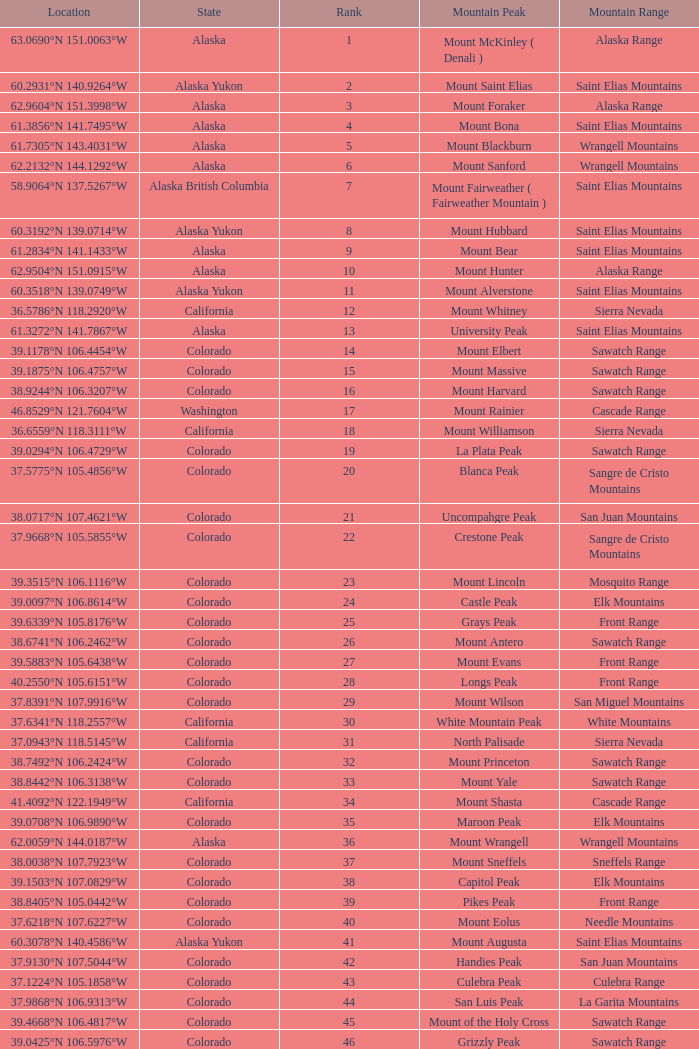What is the mountain peak when the location is 37.5775°n 105.4856°w? Blanca Peak. 